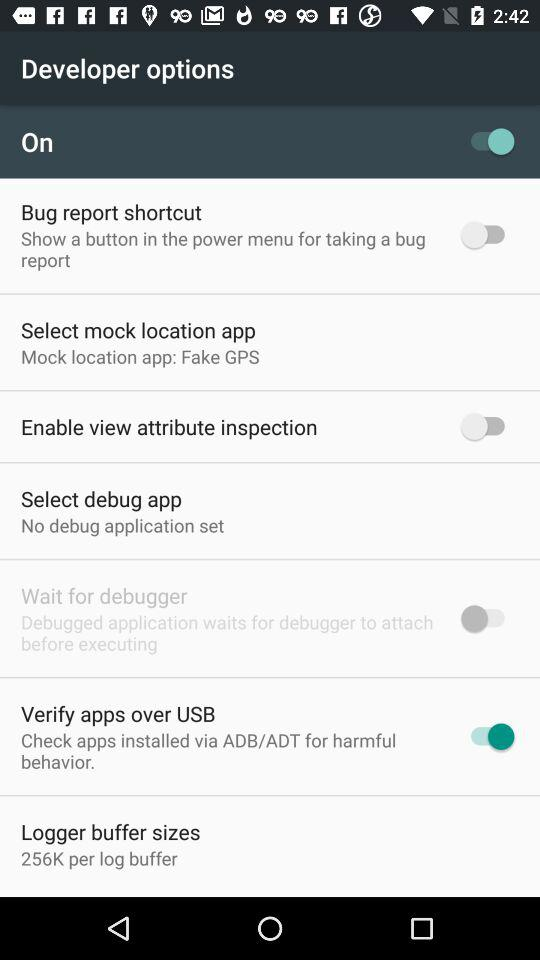What is the status of "Bug report shortcut"? The status is "off". 